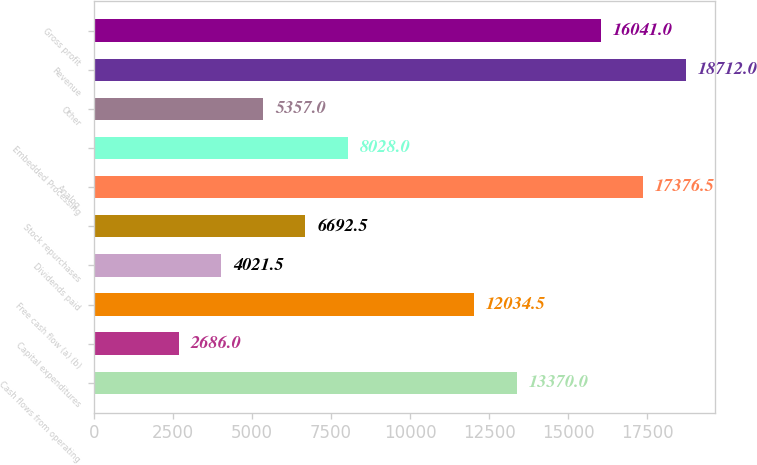<chart> <loc_0><loc_0><loc_500><loc_500><bar_chart><fcel>Cash flows from operating<fcel>Capital expenditures<fcel>Free cash flow (a) (b)<fcel>Dividends paid<fcel>Stock repurchases<fcel>Analog<fcel>Embedded Processing<fcel>Other<fcel>Revenue<fcel>Gross profit<nl><fcel>13370<fcel>2686<fcel>12034.5<fcel>4021.5<fcel>6692.5<fcel>17376.5<fcel>8028<fcel>5357<fcel>18712<fcel>16041<nl></chart> 